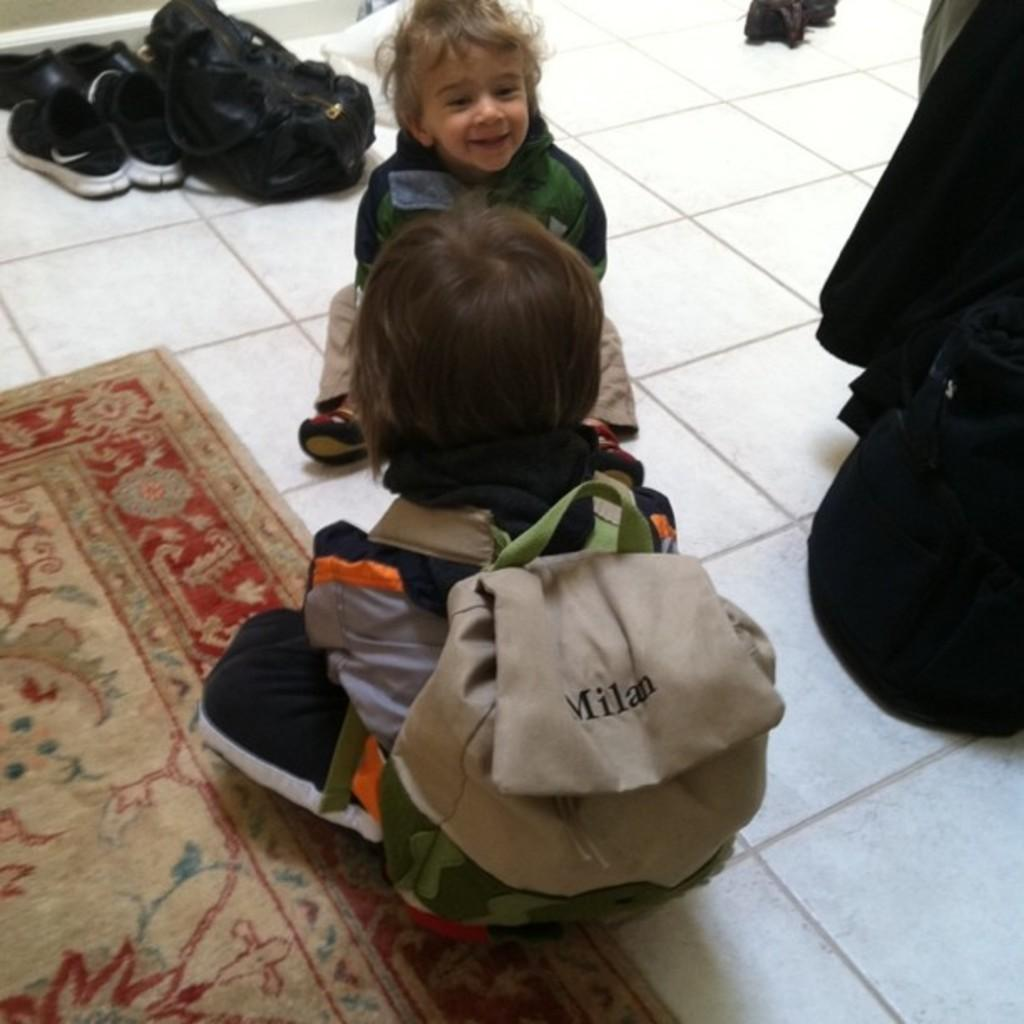What objects can be seen in the image related to footwear? There are shoes in the image. What type of bag is present in the image? There is a black color bag in the image. How many people are sitting on the floor in the image? There are two people sitting on the floor. Can you describe the child in the image? The child is sitting on the floor and is wearing a brown color bag. What is on the floor that the people are sitting on? There is a mat on the floor. Can you tell me how many trees are visible in the image? There are no trees visible in the image. Is there is any attack happening in the image? There is no attack depicted in the image. 